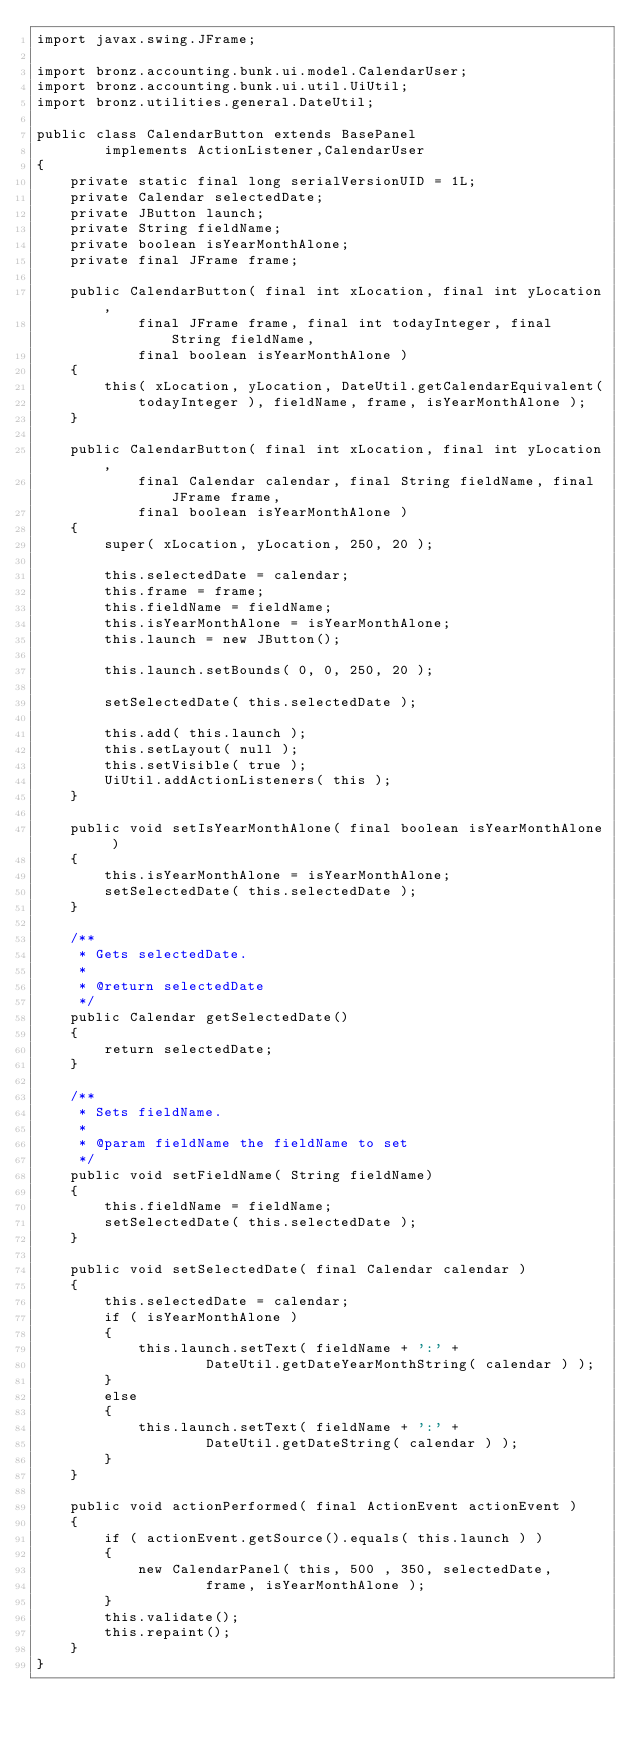Convert code to text. <code><loc_0><loc_0><loc_500><loc_500><_Java_>import javax.swing.JFrame;

import bronz.accounting.bunk.ui.model.CalendarUser;
import bronz.accounting.bunk.ui.util.UiUtil;
import bronz.utilities.general.DateUtil;

public class CalendarButton extends BasePanel
        implements ActionListener,CalendarUser
{
	private static final long serialVersionUID = 1L;
	private Calendar selectedDate;
	private JButton launch;
    private String fieldName;
    private boolean isYearMonthAlone;
    private final JFrame frame;
    
    public CalendarButton( final int xLocation, final int yLocation,
    		final JFrame frame, final int todayInteger, final String fieldName,
    		final boolean isYearMonthAlone )
    {
        this( xLocation, yLocation, DateUtil.getCalendarEquivalent(
            todayInteger ), fieldName, frame, isYearMonthAlone );
    }
	
	public CalendarButton( final int xLocation, final int yLocation,
            final Calendar calendar, final String fieldName, final JFrame frame,
            final boolean isYearMonthAlone )
	{
        super( xLocation, yLocation, 250, 20 );
        
		this.selectedDate = calendar;
		this.frame = frame;
        this.fieldName = fieldName;
        this.isYearMonthAlone = isYearMonthAlone;
        this.launch = new JButton();
		
        this.launch.setBounds( 0, 0, 250, 20 );
        
        setSelectedDate( this.selectedDate );
        
		this.add( this.launch );
		this.setLayout( null );
		this.setVisible( true );
        UiUtil.addActionListeners( this );
	}
    
    public void setIsYearMonthAlone( final boolean isYearMonthAlone )
    {
        this.isYearMonthAlone = isYearMonthAlone;
        setSelectedDate( this.selectedDate );
    }
    
	/**
     * Gets selectedDate.
     *
     * @return selectedDate
     */
    public Calendar getSelectedDate()
    {
        return selectedDate;
    }

    /**
     * Sets fieldName.
     *
     * @param fieldName the fieldName to set
     */
    public void setFieldName( String fieldName)
    {
        this.fieldName = fieldName;
        setSelectedDate( this.selectedDate );
    }

    public void setSelectedDate( final Calendar calendar )
	{
        this.selectedDate = calendar;
        if ( isYearMonthAlone )
        {
            this.launch.setText( fieldName + ':' +
                    DateUtil.getDateYearMonthString( calendar ) );
        }
        else
        {
            this.launch.setText( fieldName + ':' +
                    DateUtil.getDateString( calendar ) );
        }
	}
	
	public void actionPerformed( final ActionEvent actionEvent )
	{
		if ( actionEvent.getSource().equals( this.launch ) )
		{
            new CalendarPanel( this, 500 , 350, selectedDate,
            		frame, isYearMonthAlone );
		}
		this.validate();
		this.repaint();
	}
}
</code> 